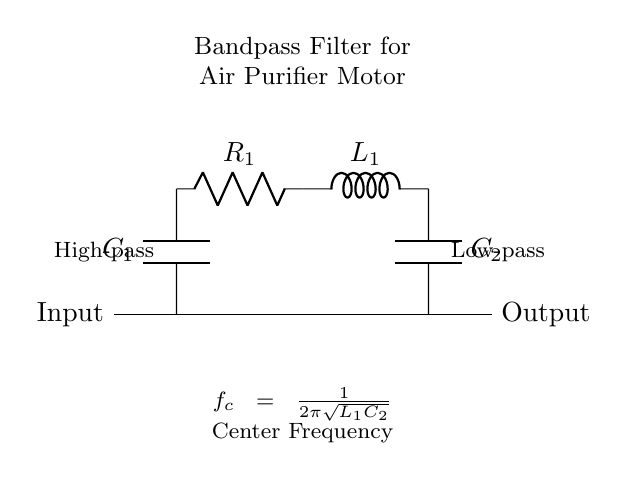What components are used in this circuit? The circuit consists of a capacitor (C1), a resistor (R1), an inductor (L1), and another capacitor (C2). These components are explicitly labeled in the diagram.
Answer: capacitor, resistor, inductor, capacitor What is the function of this circuit? This circuit serves as a bandpass filter, which allows signals within a certain frequency range to pass while attenuating frequencies outside this range. This functionality is indicated by the labels for high-pass and low-pass sections.
Answer: bandpass filter What is the center frequency formula? The center frequency (f_c) is given by the formula f_c equals one divided by two pi times the square root of L1 times C2. This formula is stated below the circuit diagram.
Answer: f_c = 1 / (2π√(L1C2)) What type of filter does this circuit represent? This circuit represents a bandpass filter, as indicated by the integration of both high-pass and low-pass characteristics to allow a specific range of frequencies to pass.
Answer: bandpass filter What is the role of the inductor in this circuit? The inductor (L1) contributes to the low-pass filter characteristics by blocking high-frequency signals and allowing low-frequency signals to pass through. This can be inferred from the arrangement and labeling next to the inductor in the circuit diagram.
Answer: blocks high frequencies Which component is connected in parallel with C1 and L1? C2 is connected in parallel with the series combination of C1 and R1, creating the high-pass section of the filter. This relationship is implied by the connections drawn in the circuit.
Answer: C2 